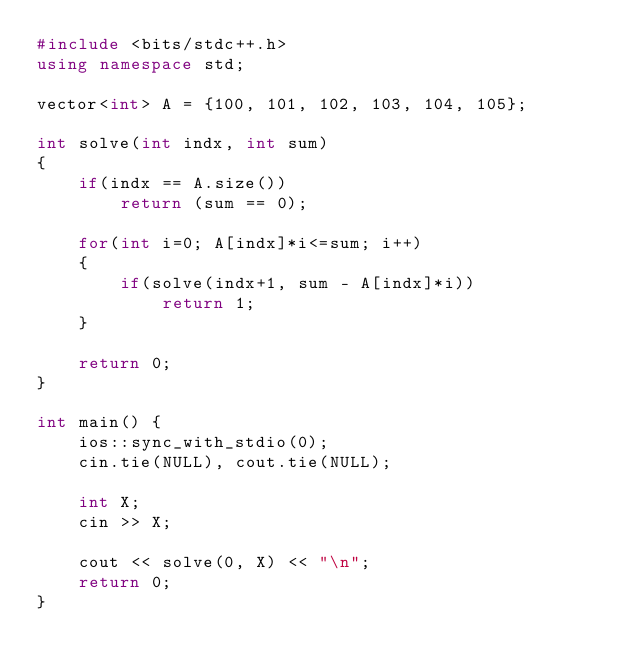Convert code to text. <code><loc_0><loc_0><loc_500><loc_500><_C++_>#include <bits/stdc++.h>
using namespace std;

vector<int> A = {100, 101, 102, 103, 104, 105};

int solve(int indx, int sum)
{
    if(indx == A.size())
        return (sum == 0);

    for(int i=0; A[indx]*i<=sum; i++)
    {
        if(solve(indx+1, sum - A[indx]*i))
            return 1;
    }

    return 0;
}

int main() {
    ios::sync_with_stdio(0);
    cin.tie(NULL), cout.tie(NULL);

    int X;
    cin >> X;

    cout << solve(0, X) << "\n";
    return 0;
}
</code> 